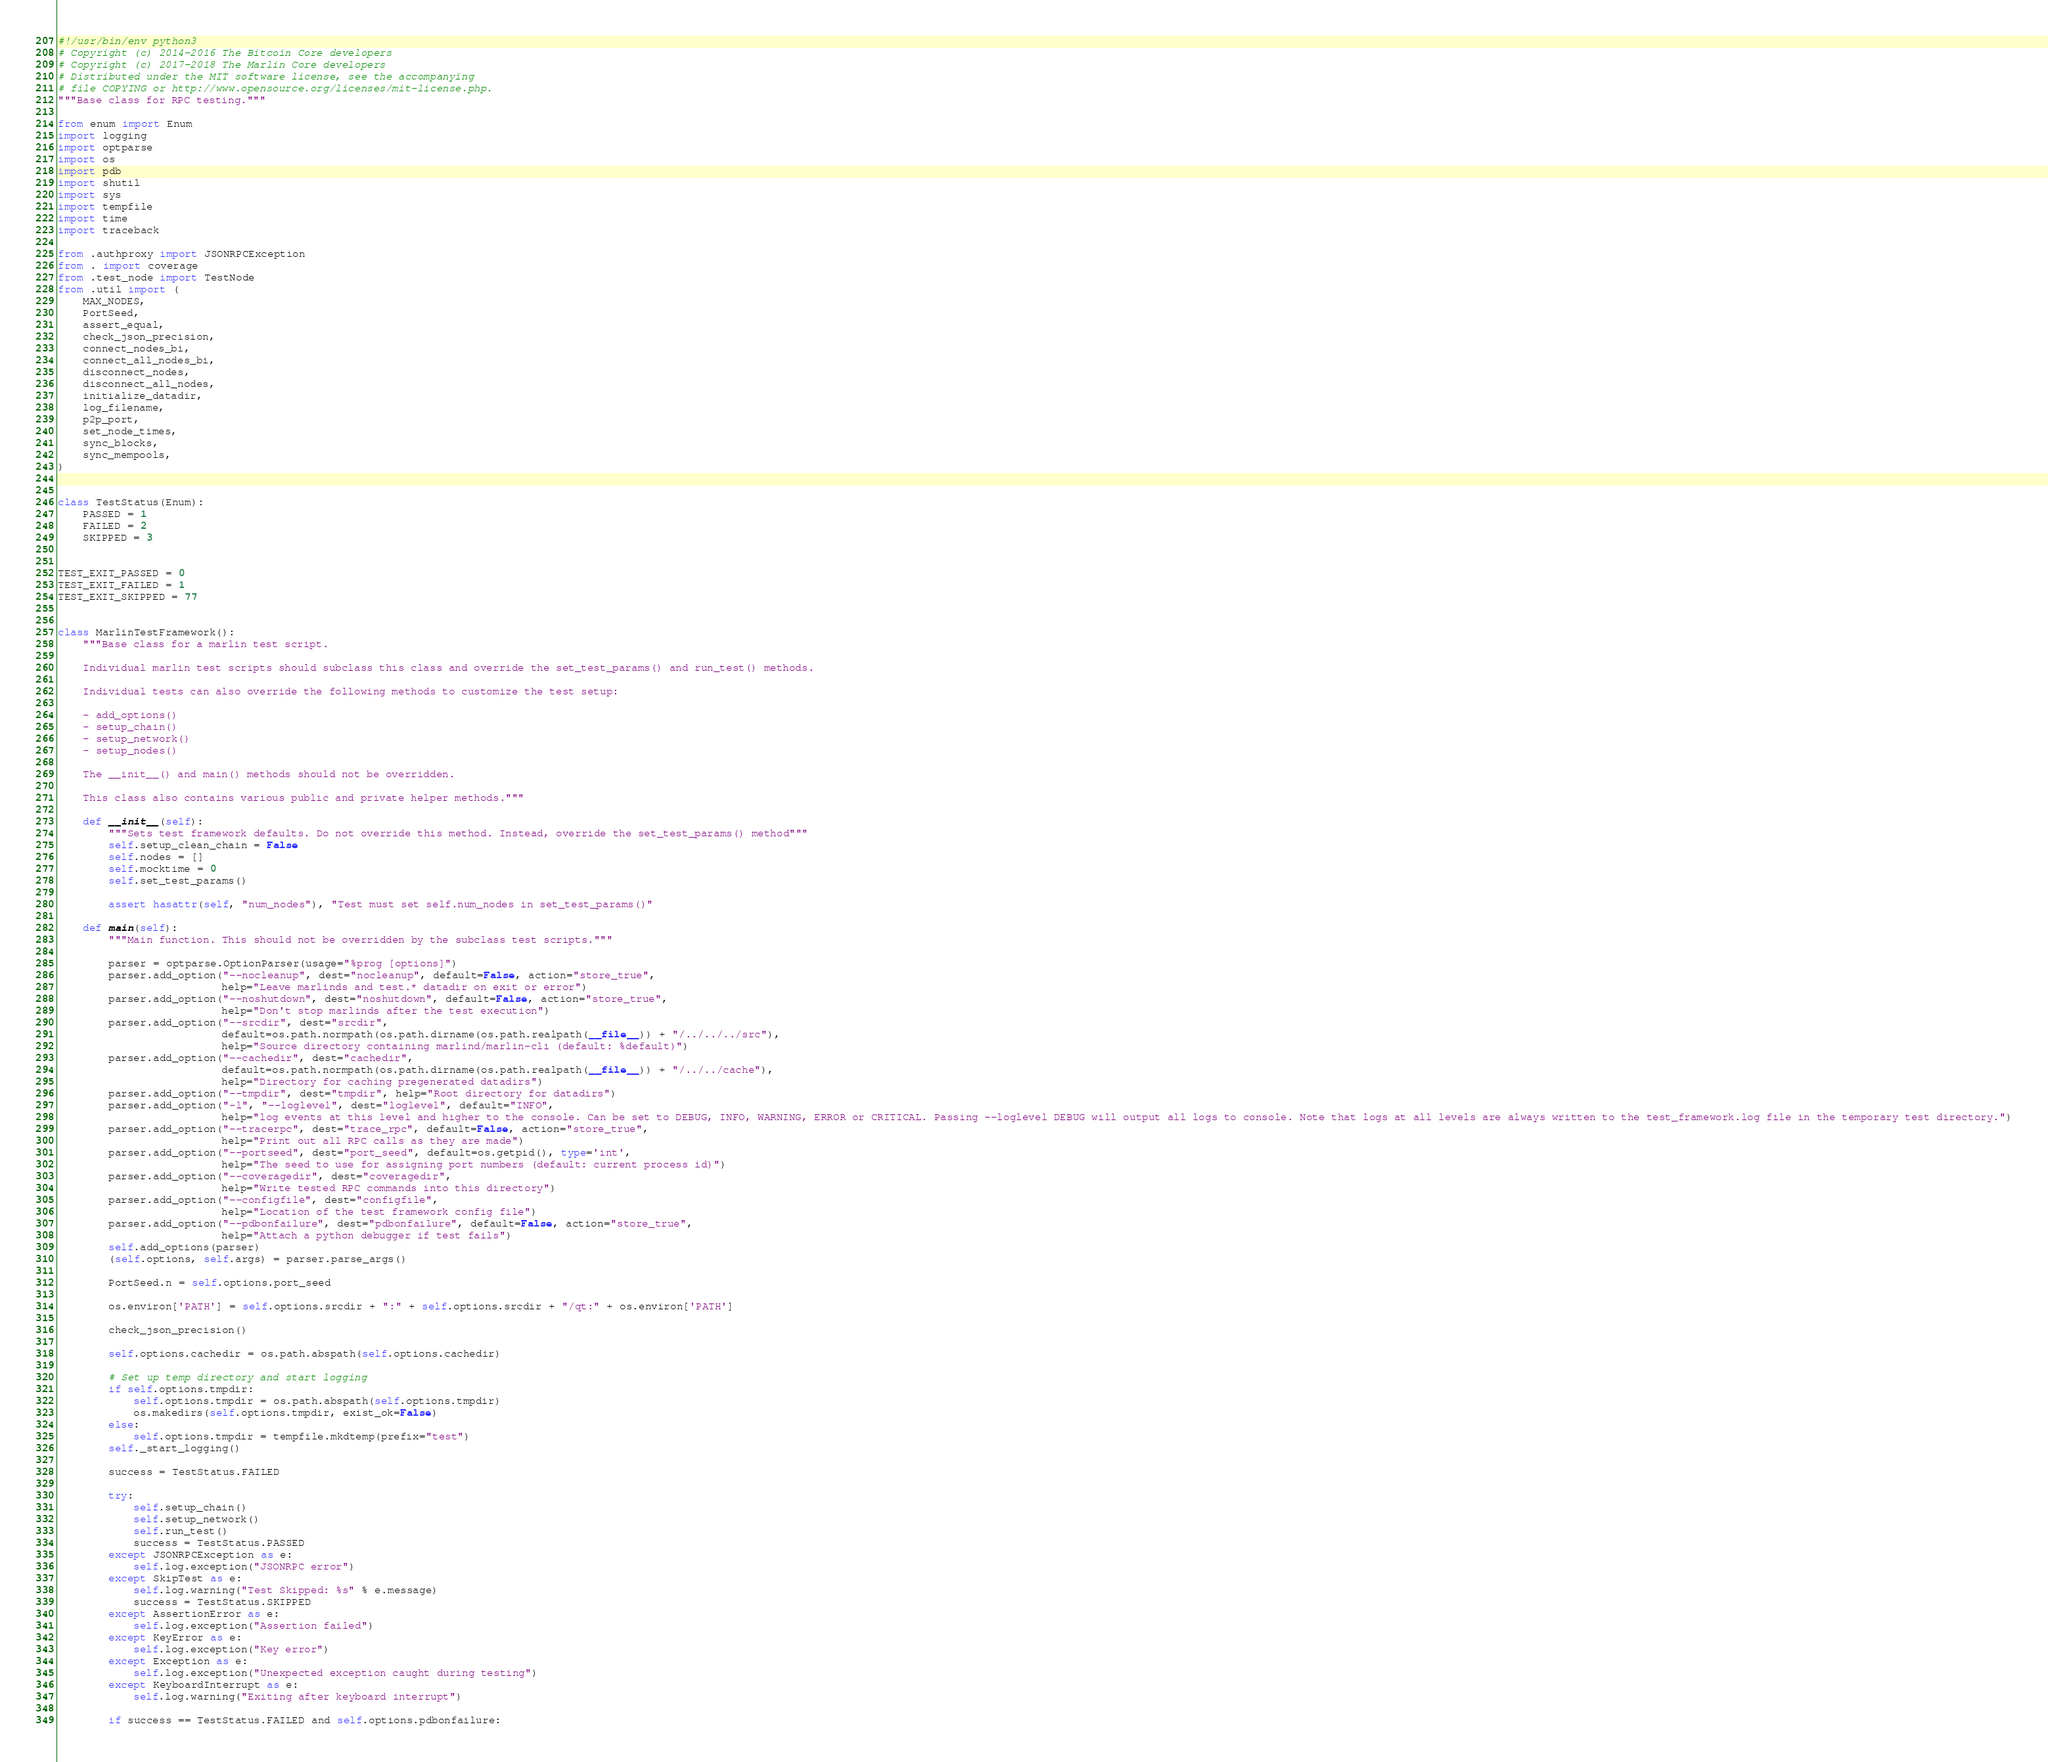<code> <loc_0><loc_0><loc_500><loc_500><_Python_>#!/usr/bin/env python3
# Copyright (c) 2014-2016 The Bitcoin Core developers
# Copyright (c) 2017-2018 The Marlin Core developers
# Distributed under the MIT software license, see the accompanying
# file COPYING or http://www.opensource.org/licenses/mit-license.php.
"""Base class for RPC testing."""

from enum import Enum
import logging
import optparse
import os
import pdb
import shutil
import sys
import tempfile
import time
import traceback

from .authproxy import JSONRPCException
from . import coverage
from .test_node import TestNode
from .util import (
    MAX_NODES,
    PortSeed,
    assert_equal,
    check_json_precision,
    connect_nodes_bi,
    connect_all_nodes_bi,
    disconnect_nodes,
    disconnect_all_nodes,
    initialize_datadir,
    log_filename,
    p2p_port,
    set_node_times,
    sync_blocks,
    sync_mempools,
)


class TestStatus(Enum):
    PASSED = 1
    FAILED = 2
    SKIPPED = 3


TEST_EXIT_PASSED = 0
TEST_EXIT_FAILED = 1
TEST_EXIT_SKIPPED = 77


class MarlinTestFramework():
    """Base class for a marlin test script.

    Individual marlin test scripts should subclass this class and override the set_test_params() and run_test() methods.

    Individual tests can also override the following methods to customize the test setup:

    - add_options()
    - setup_chain()
    - setup_network()
    - setup_nodes()

    The __init__() and main() methods should not be overridden.

    This class also contains various public and private helper methods."""

    def __init__(self):
        """Sets test framework defaults. Do not override this method. Instead, override the set_test_params() method"""
        self.setup_clean_chain = False
        self.nodes = []
        self.mocktime = 0
        self.set_test_params()

        assert hasattr(self, "num_nodes"), "Test must set self.num_nodes in set_test_params()"

    def main(self):
        """Main function. This should not be overridden by the subclass test scripts."""

        parser = optparse.OptionParser(usage="%prog [options]")
        parser.add_option("--nocleanup", dest="nocleanup", default=False, action="store_true",
                          help="Leave marlinds and test.* datadir on exit or error")
        parser.add_option("--noshutdown", dest="noshutdown", default=False, action="store_true",
                          help="Don't stop marlinds after the test execution")
        parser.add_option("--srcdir", dest="srcdir",
                          default=os.path.normpath(os.path.dirname(os.path.realpath(__file__)) + "/../../../src"),
                          help="Source directory containing marlind/marlin-cli (default: %default)")
        parser.add_option("--cachedir", dest="cachedir",
                          default=os.path.normpath(os.path.dirname(os.path.realpath(__file__)) + "/../../cache"),
                          help="Directory for caching pregenerated datadirs")
        parser.add_option("--tmpdir", dest="tmpdir", help="Root directory for datadirs")
        parser.add_option("-l", "--loglevel", dest="loglevel", default="INFO",
                          help="log events at this level and higher to the console. Can be set to DEBUG, INFO, WARNING, ERROR or CRITICAL. Passing --loglevel DEBUG will output all logs to console. Note that logs at all levels are always written to the test_framework.log file in the temporary test directory.")
        parser.add_option("--tracerpc", dest="trace_rpc", default=False, action="store_true",
                          help="Print out all RPC calls as they are made")
        parser.add_option("--portseed", dest="port_seed", default=os.getpid(), type='int',
                          help="The seed to use for assigning port numbers (default: current process id)")
        parser.add_option("--coveragedir", dest="coveragedir",
                          help="Write tested RPC commands into this directory")
        parser.add_option("--configfile", dest="configfile",
                          help="Location of the test framework config file")
        parser.add_option("--pdbonfailure", dest="pdbonfailure", default=False, action="store_true",
                          help="Attach a python debugger if test fails")
        self.add_options(parser)
        (self.options, self.args) = parser.parse_args()

        PortSeed.n = self.options.port_seed

        os.environ['PATH'] = self.options.srcdir + ":" + self.options.srcdir + "/qt:" + os.environ['PATH']

        check_json_precision()

        self.options.cachedir = os.path.abspath(self.options.cachedir)

        # Set up temp directory and start logging
        if self.options.tmpdir:
            self.options.tmpdir = os.path.abspath(self.options.tmpdir)
            os.makedirs(self.options.tmpdir, exist_ok=False)
        else:
            self.options.tmpdir = tempfile.mkdtemp(prefix="test")
        self._start_logging()

        success = TestStatus.FAILED

        try:
            self.setup_chain()
            self.setup_network()
            self.run_test()
            success = TestStatus.PASSED
        except JSONRPCException as e:
            self.log.exception("JSONRPC error")
        except SkipTest as e:
            self.log.warning("Test Skipped: %s" % e.message)
            success = TestStatus.SKIPPED
        except AssertionError as e:
            self.log.exception("Assertion failed")
        except KeyError as e:
            self.log.exception("Key error")
        except Exception as e:
            self.log.exception("Unexpected exception caught during testing")
        except KeyboardInterrupt as e:
            self.log.warning("Exiting after keyboard interrupt")

        if success == TestStatus.FAILED and self.options.pdbonfailure:</code> 